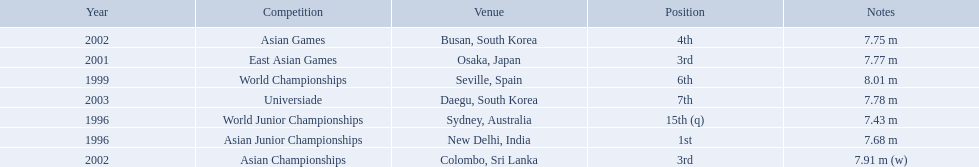What competitions did huang le compete in? World Junior Championships, Asian Junior Championships, World Championships, East Asian Games, Asian Championships, Asian Games, Universiade. What distances did he achieve in these competitions? 7.43 m, 7.68 m, 8.01 m, 7.77 m, 7.91 m (w), 7.75 m, 7.78 m. Which of these distances was the longest? 7.91 m (w). 